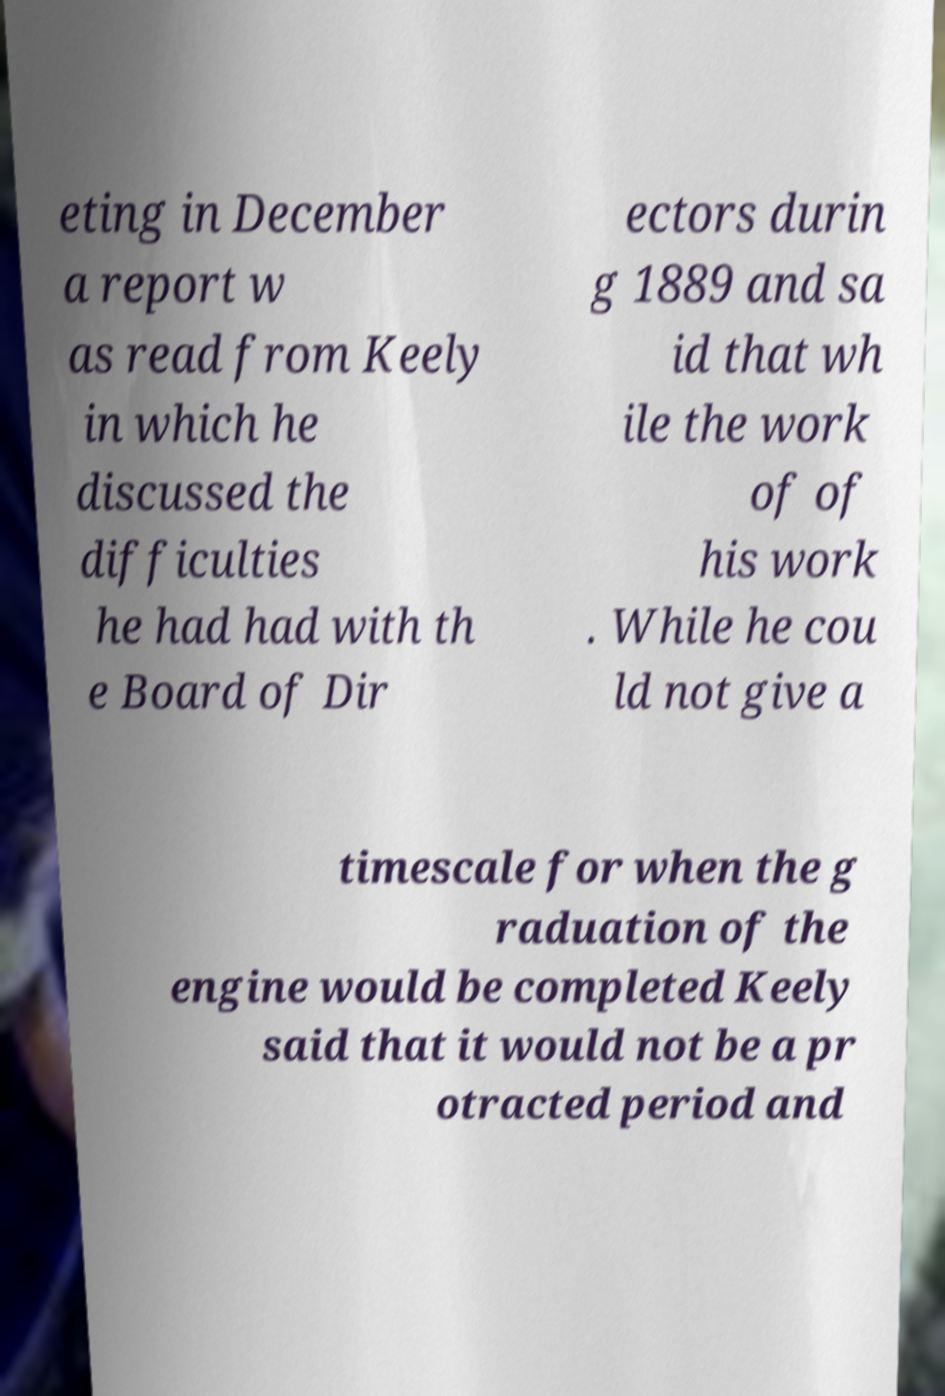Can you accurately transcribe the text from the provided image for me? eting in December a report w as read from Keely in which he discussed the difficulties he had had with th e Board of Dir ectors durin g 1889 and sa id that wh ile the work of of his work . While he cou ld not give a timescale for when the g raduation of the engine would be completed Keely said that it would not be a pr otracted period and 